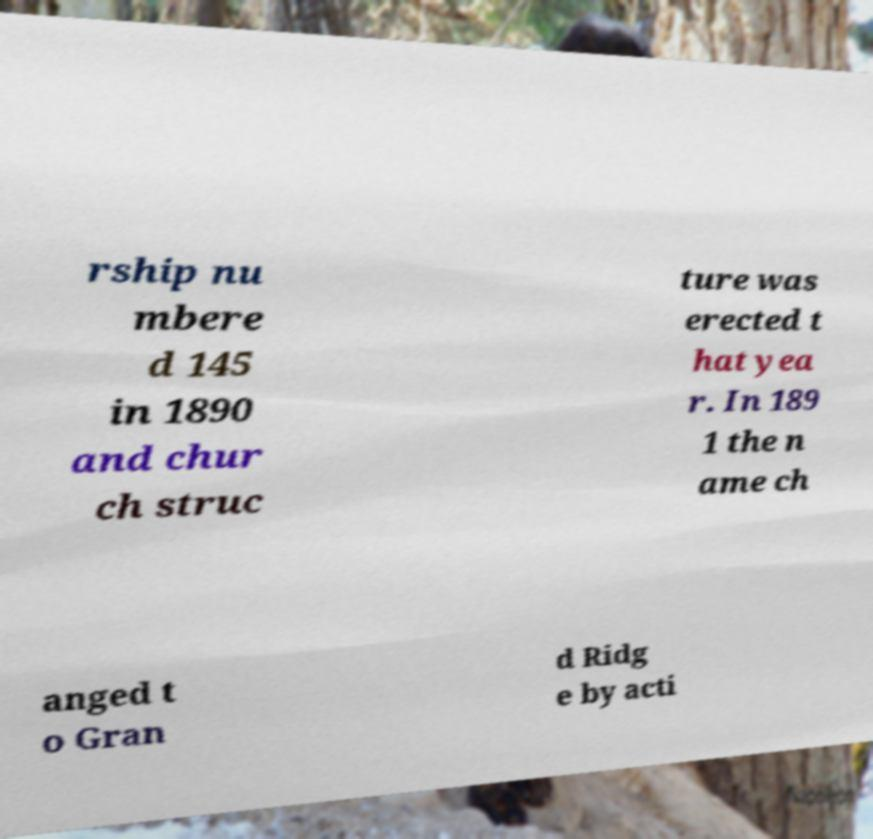Please read and relay the text visible in this image. What does it say? rship nu mbere d 145 in 1890 and chur ch struc ture was erected t hat yea r. In 189 1 the n ame ch anged t o Gran d Ridg e by acti 